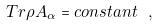Convert formula to latex. <formula><loc_0><loc_0><loc_500><loc_500>T r \rho A _ { \alpha } = c o n s t a n t \ ,</formula> 